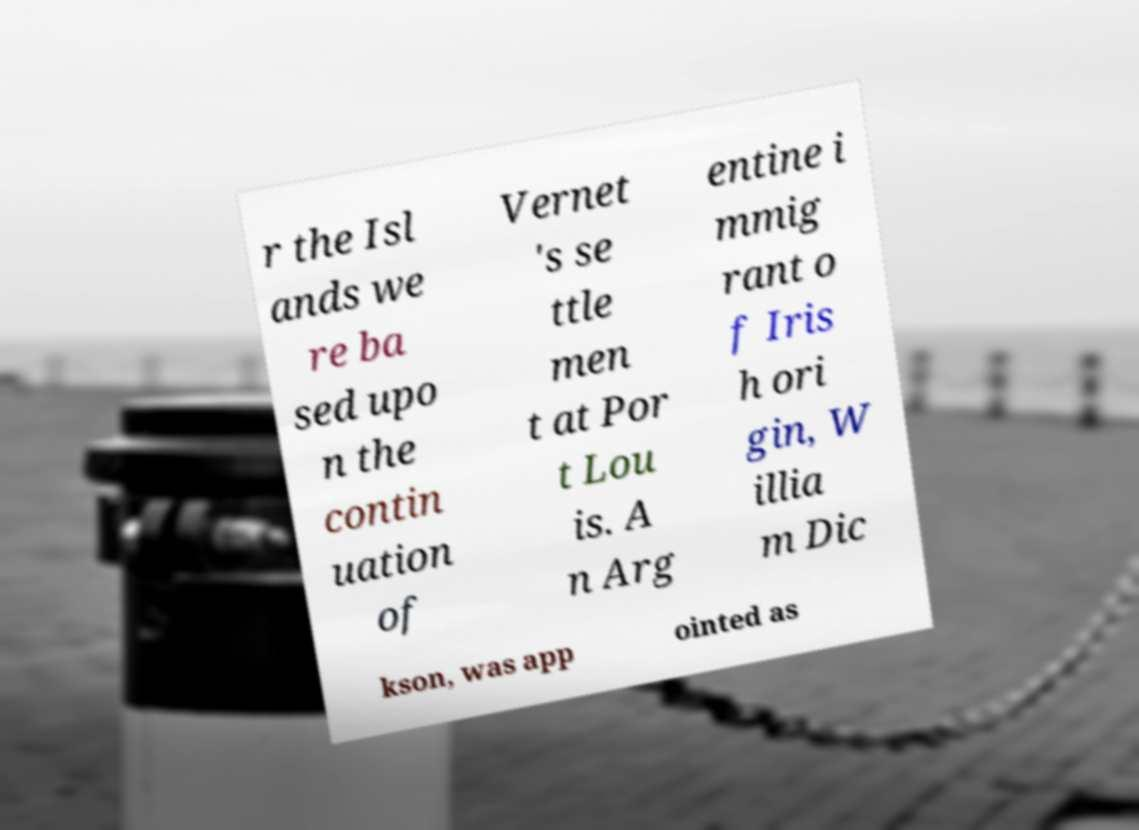There's text embedded in this image that I need extracted. Can you transcribe it verbatim? r the Isl ands we re ba sed upo n the contin uation of Vernet 's se ttle men t at Por t Lou is. A n Arg entine i mmig rant o f Iris h ori gin, W illia m Dic kson, was app ointed as 